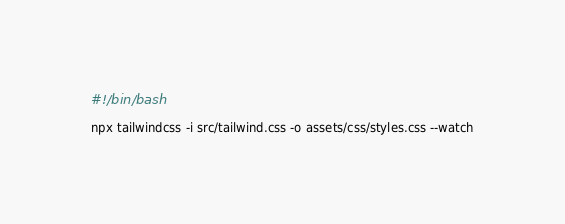<code> <loc_0><loc_0><loc_500><loc_500><_Bash_>#!/bin/bash

npx tailwindcss -i src/tailwind.css -o assets/css/styles.css --watch
</code> 